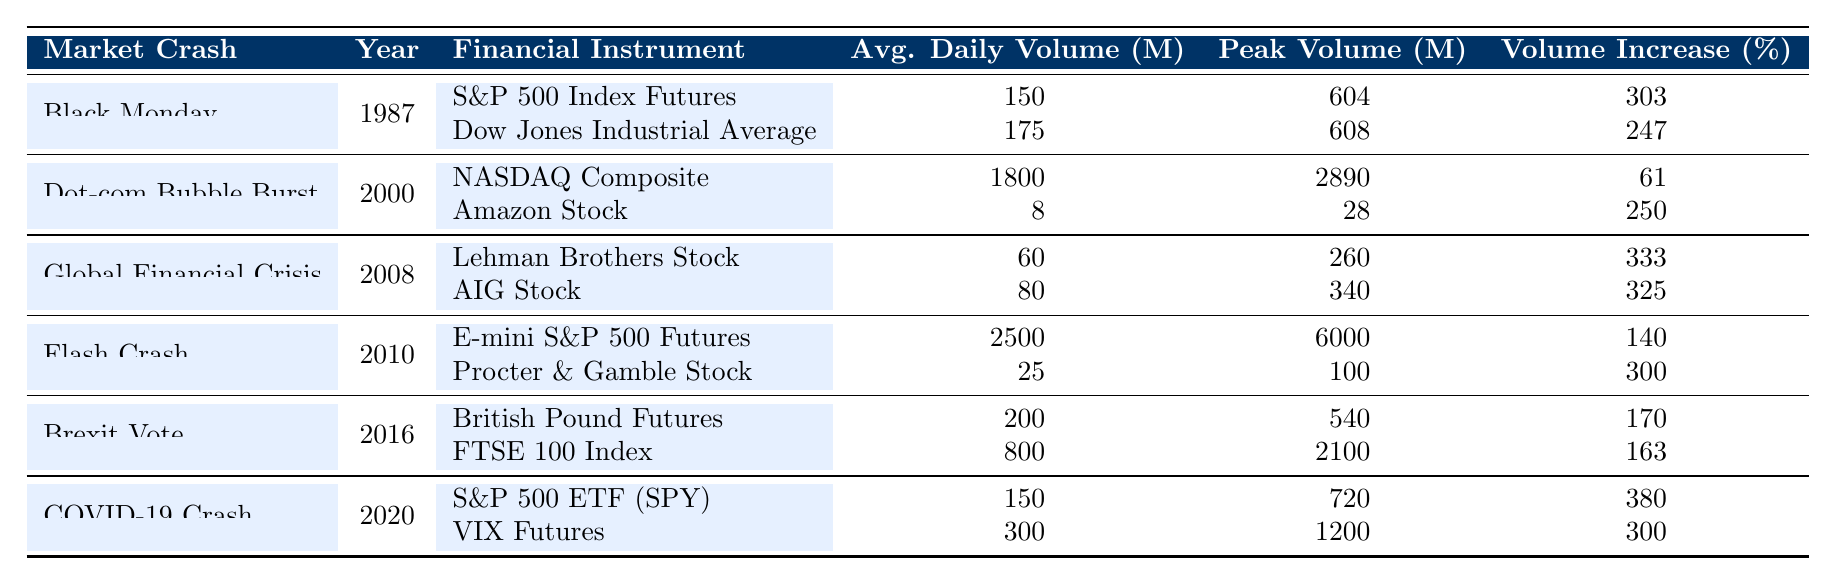What was the peak trading volume for the S&P 500 Index Futures during Black Monday? The peak trading volume is listed in the table under "Peak Trading Volume (Millions)" for "S&P 500 Index Futures" during "Black Monday." It shows 604 million.
Answer: 604 million Which financial instrument had the highest average daily trading volume during the Flash Crash? The average daily trading volume for the "E-mini S&P 500 Futures" under "Flash Crash" is 2500 million, which is higher than any other financial instrument listed in that market crash.
Answer: E-mini S&P 500 Futures What was the percentage increase of trading volume for Amazon Stock during the Dot-com Bubble Burst? The percentage increase for "Amazon Stock" during the "Dot-com Bubble Burst" is noted in the "Volume Increase (%)" column as 250%.
Answer: 250% Was the average daily trading volume during the COVID-19 Crash for VIX Futures higher than for Lehman Brothers Stock during the Global Financial Crisis? The average daily trading volume for "VIX Futures" during the "COVID-19 Crash" is 300 million, while for "Lehman Brothers Stock" during the "Global Financial Crisis," it is only 60 million, which confirms the statement as true.
Answer: Yes Calculate the difference in peak trading volume between the FTSE 100 Index and Dow Jones Industrial Average. The "Peak Volume (Millions)" for the "FTSE 100 Index" is 2100 million, and for the "Dow Jones Industrial Average," it is 608 million. The difference is calculated as 2100 - 608 = 1492 million.
Answer: 1492 million What is the average volume increase percentage across all instruments listed for the year 2020? The volume increase percentages for the financial instruments in 2020 are 380% for "S&P 500 ETF (SPY)" and 300% for "VIX Futures." Adding these gives 680%, and dividing by 2 (the number of instruments) gives 340%.
Answer: 340% Which market crash in the table had the lowest average daily trading volume combined? By reviewing the average daily trading volumes, the "Global Financial Crisis" has the lowest combined average daily trading volume of 60 + 80 = 140 million.
Answer: Global Financial Crisis What was the combined peak trading volume for all financial instruments listed under the Dot-com Bubble Burst? The peak volumes for the "Dot-com Bubble Burst" are 2890 million for the NASDAQ Composite and 28 million for Amazon Stock. Summing these gives 2890 + 28 = 2918 million.
Answer: 2918 million Did the average daily trading volume increase for British Pound Futures during the Brexit Vote compared to the previous year? The table only includes data for the Brexit Vote in 2016, so we cannot compare it to a previous year. Therefore, the answer is false.
Answer: No 